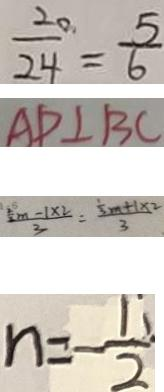Convert formula to latex. <formula><loc_0><loc_0><loc_500><loc_500>\frac { 2 0 } { 2 4 } = \frac { 5 } { 6 } 
 A D \bot B C 
 \frac { \frac { 2 } { 2 } m - 1 \times 2 } { 3 } = \frac { \frac { 1 } { 3 } m + 1 \times 2 } { 3 } 
 n = - \frac { 1 } { 2 }</formula> 